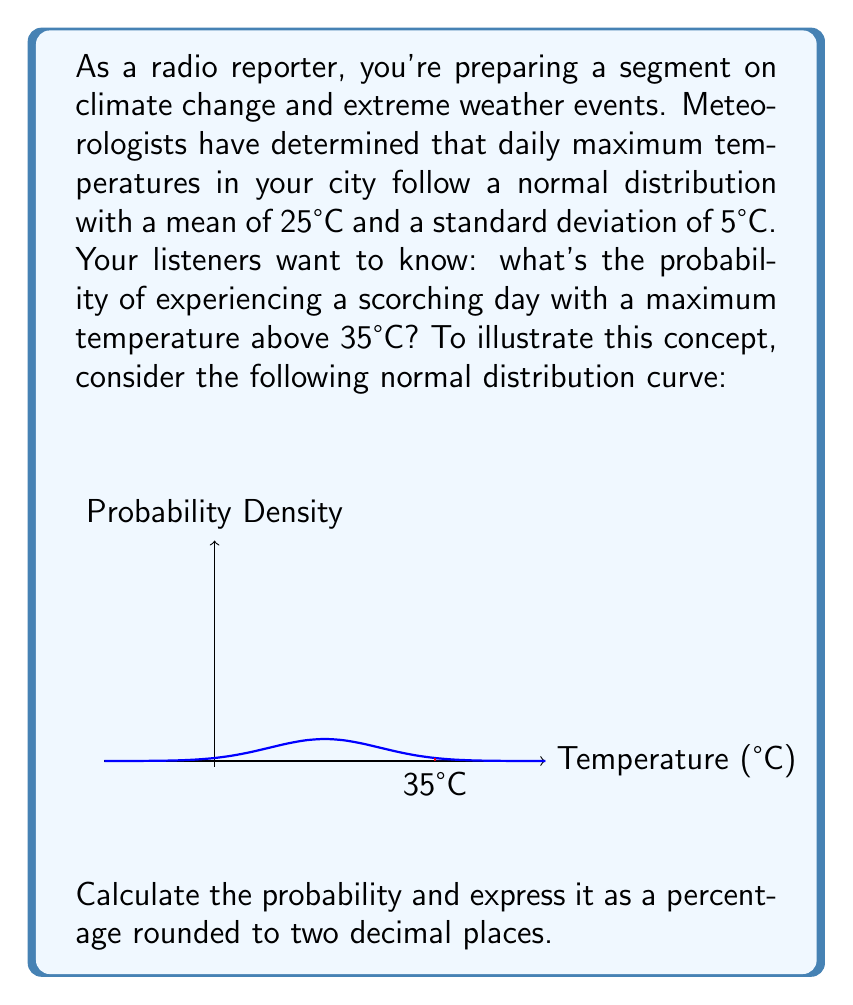Solve this math problem. Let's approach this step-by-step:

1) We're dealing with a normal distribution where:
   Mean (μ) = 25°C
   Standard deviation (σ) = 5°C

2) We want to find P(X > 35), where X is the daily maximum temperature.

3) To use the standard normal distribution table, we need to convert 35°C to a z-score:

   $$z = \frac{x - \mu}{\sigma} = \frac{35 - 25}{5} = 2$$

4) Now, we need to find P(Z > 2) where Z is the standard normal variable.

5) Using a standard normal table or calculator, we can find that:
   P(Z < 2) ≈ 0.9772

6) Since we want P(Z > 2), and the total probability is 1:
   P(Z > 2) = 1 - P(Z < 2) = 1 - 0.9772 = 0.0228

7) Converting to a percentage:
   0.0228 * 100 = 2.28%

Therefore, the probability of experiencing a day with a maximum temperature above 35°C is approximately 2.28%.
Answer: 2.28% 